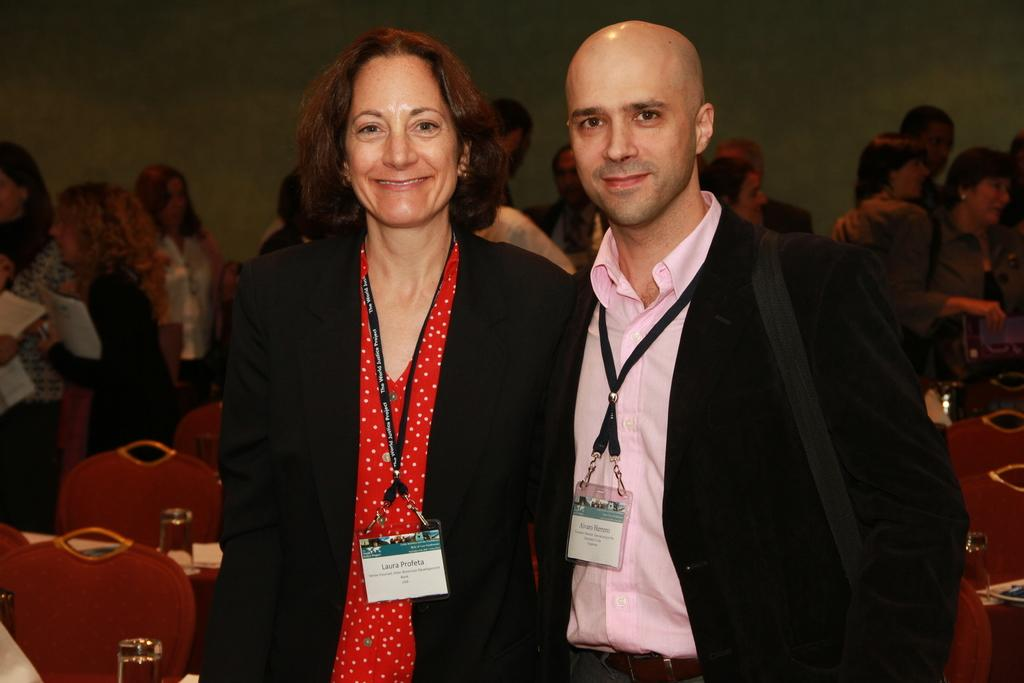Who or what can be seen in the image? There are people in the image. What objects are present that the people might use? There are chairs and glasses visible in the image. What can be seen in the background of the image? There is a wall visible in the background of the image. How many geese are sitting on the chairs in the image? There are no geese present in the image; it features people, chairs, and glasses. What type of sign can be seen hanging on the wall in the image? There is no sign visible on the wall in the image; only a wall is present in the background. 